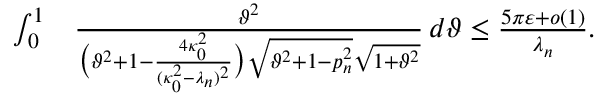Convert formula to latex. <formula><loc_0><loc_0><loc_500><loc_500>\begin{array} { r l } { \int _ { 0 } ^ { 1 } } & { \frac { \vartheta ^ { 2 } } { \left ( \vartheta ^ { 2 } + 1 - \frac { 4 \kappa _ { 0 } ^ { 2 } } { ( \kappa _ { 0 } ^ { 2 } - \lambda _ { n } ) ^ { 2 } } \right ) \sqrt { \vartheta ^ { 2 } + 1 - p _ { n } ^ { 2 } } \sqrt { 1 + \vartheta ^ { 2 } } } \, d \vartheta \leq \frac { 5 \pi \varepsilon + o ( 1 ) } { \lambda _ { n } } . } \end{array}</formula> 